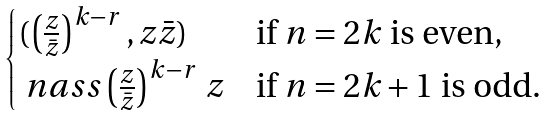<formula> <loc_0><loc_0><loc_500><loc_500>\begin{cases} ( \left ( \frac { z } { \bar { z } } \right ) ^ { k - r } , z \bar { z } ) & \text {if $n=2k$ is even,} \\ \ n a s s \left ( \frac { z } { \bar { z } } \right ) ^ { k - r } \, z & \text {if $n=2k+1$ is odd.} \end{cases}</formula> 